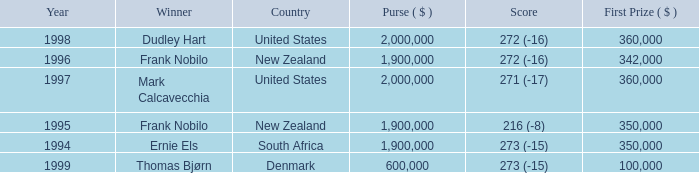What was the top first place prize in 1997? 360000.0. 